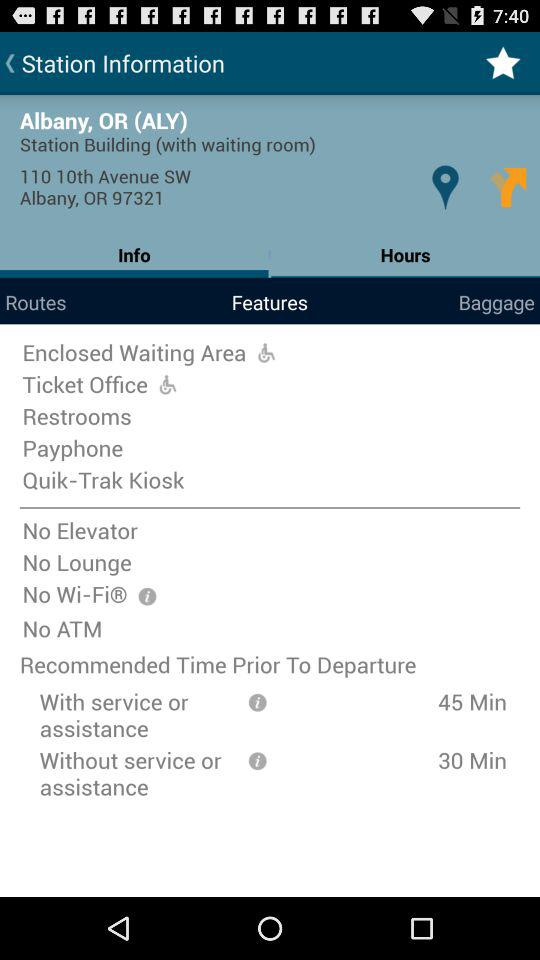How much time is recommended prior to departure without service or assistance? The recommended time is 30 minutes. 